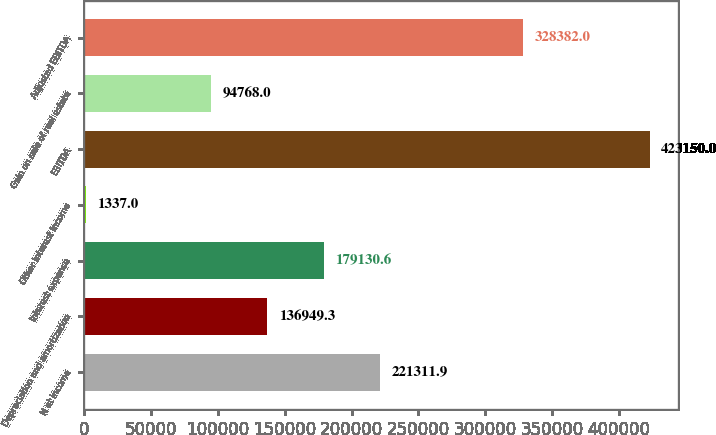Convert chart. <chart><loc_0><loc_0><loc_500><loc_500><bar_chart><fcel>N et income<fcel>Depreciation and amortization<fcel>Interest expense<fcel>Other interest income<fcel>EBITDA<fcel>Gain on sale of real estate<fcel>Adjusted EBITDA<nl><fcel>221312<fcel>136949<fcel>179131<fcel>1337<fcel>423150<fcel>94768<fcel>328382<nl></chart> 